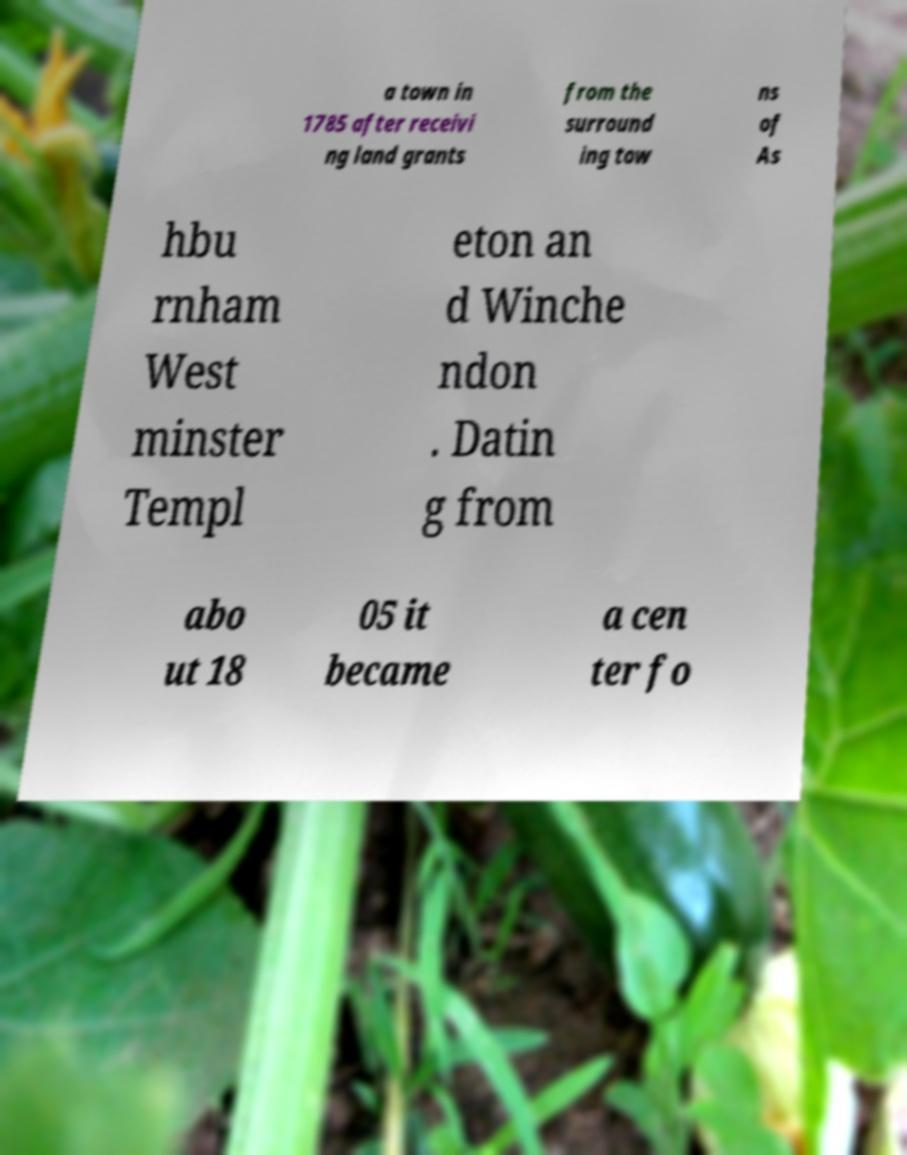Can you accurately transcribe the text from the provided image for me? a town in 1785 after receivi ng land grants from the surround ing tow ns of As hbu rnham West minster Templ eton an d Winche ndon . Datin g from abo ut 18 05 it became a cen ter fo 